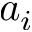<formula> <loc_0><loc_0><loc_500><loc_500>a _ { i }</formula> 